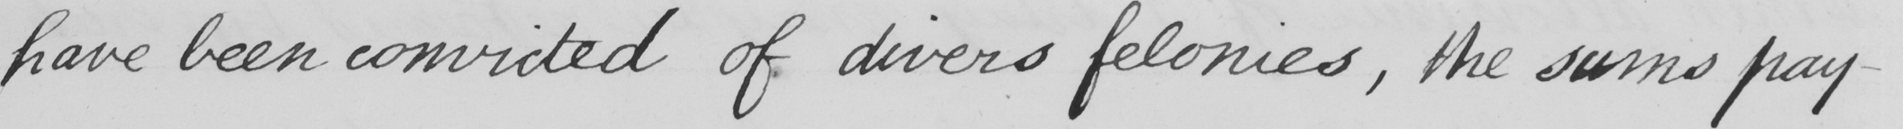Please provide the text content of this handwritten line. have been convicted of divers felonies , the sums pay- 